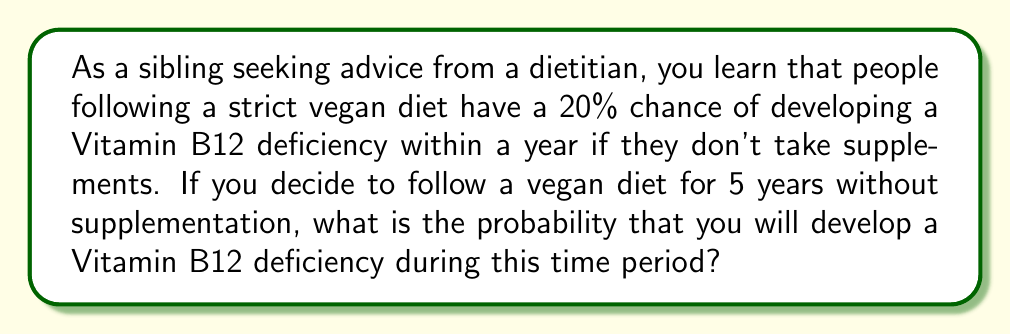Give your solution to this math problem. To solve this problem, we need to consider the probability of not developing a deficiency for each year and then calculate the probability of developing a deficiency over the 5-year period.

1. Probability of developing a deficiency in one year: $p = 0.20$ or $20\%$

2. Probability of not developing a deficiency in one year: $1 - p = 1 - 0.20 = 0.80$ or $80\%$

3. Probability of not developing a deficiency for 5 years:
   $$(0.80)^5 = 0.32768$$

4. Probability of developing a deficiency within 5 years:
   $$1 - (0.80)^5 = 1 - 0.32768 = 0.67232$$

This can also be expressed as a percentage:
   $$0.67232 \times 100\% = 67.232\%$$

The calculation uses the complement rule of probability. We first calculate the probability of not developing a deficiency over 5 years (by raising the probability of not developing a deficiency in one year to the power of 5), and then subtract this from 1 to get the probability of developing a deficiency within the 5-year period.
Answer: The probability of developing a Vitamin B12 deficiency within 5 years on a strict vegan diet without supplementation is approximately $0.67232$ or $67.232\%$. 